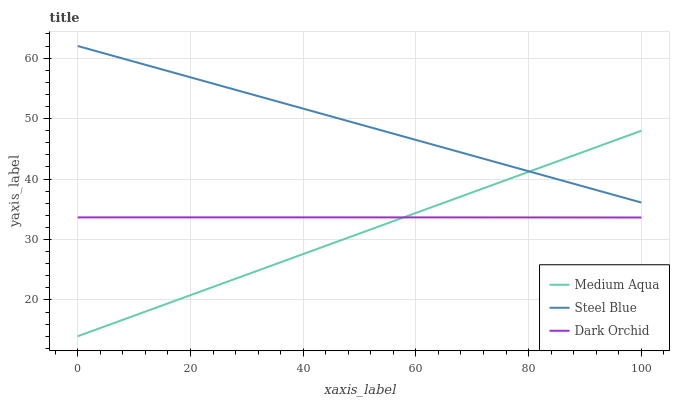Does Medium Aqua have the minimum area under the curve?
Answer yes or no. Yes. Does Steel Blue have the maximum area under the curve?
Answer yes or no. Yes. Does Dark Orchid have the minimum area under the curve?
Answer yes or no. No. Does Dark Orchid have the maximum area under the curve?
Answer yes or no. No. Is Medium Aqua the smoothest?
Answer yes or no. Yes. Is Dark Orchid the roughest?
Answer yes or no. Yes. Is Steel Blue the smoothest?
Answer yes or no. No. Is Steel Blue the roughest?
Answer yes or no. No. Does Medium Aqua have the lowest value?
Answer yes or no. Yes. Does Dark Orchid have the lowest value?
Answer yes or no. No. Does Steel Blue have the highest value?
Answer yes or no. Yes. Does Dark Orchid have the highest value?
Answer yes or no. No. Is Dark Orchid less than Steel Blue?
Answer yes or no. Yes. Is Steel Blue greater than Dark Orchid?
Answer yes or no. Yes. Does Medium Aqua intersect Dark Orchid?
Answer yes or no. Yes. Is Medium Aqua less than Dark Orchid?
Answer yes or no. No. Is Medium Aqua greater than Dark Orchid?
Answer yes or no. No. Does Dark Orchid intersect Steel Blue?
Answer yes or no. No. 